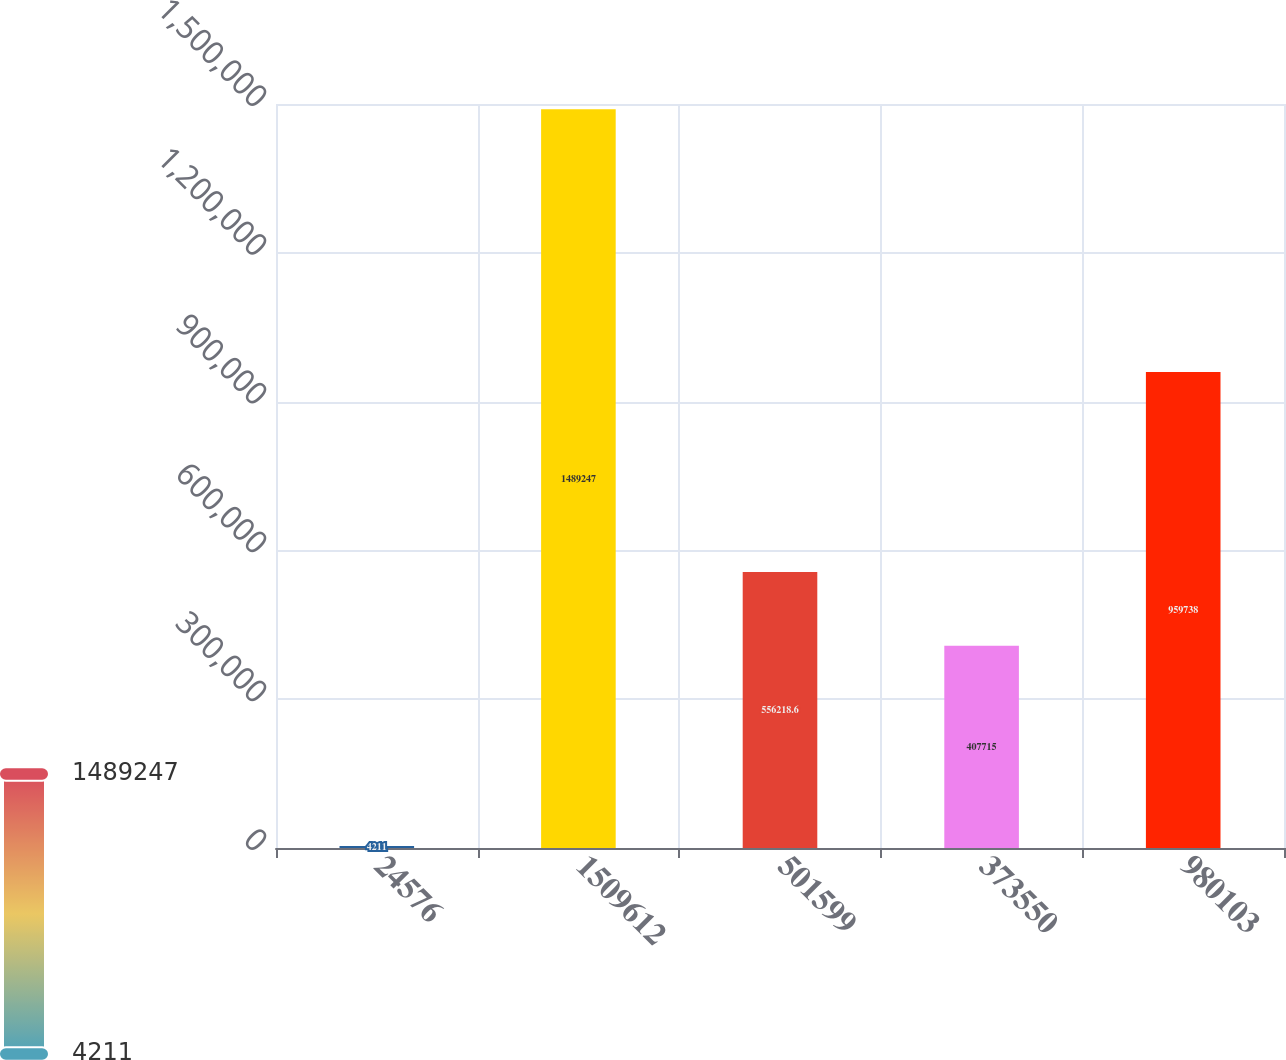Convert chart. <chart><loc_0><loc_0><loc_500><loc_500><bar_chart><fcel>24576<fcel>1509612<fcel>501599<fcel>373550<fcel>980103<nl><fcel>4211<fcel>1.48925e+06<fcel>556219<fcel>407715<fcel>959738<nl></chart> 